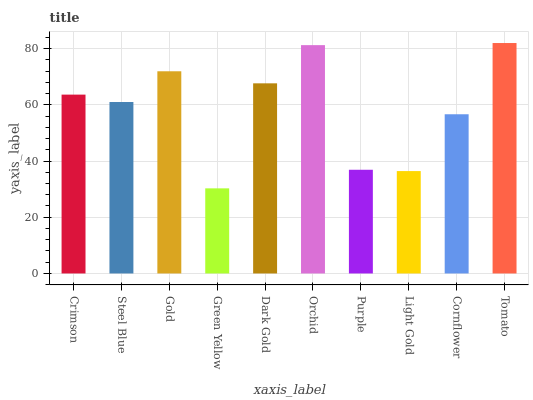Is Green Yellow the minimum?
Answer yes or no. Yes. Is Tomato the maximum?
Answer yes or no. Yes. Is Steel Blue the minimum?
Answer yes or no. No. Is Steel Blue the maximum?
Answer yes or no. No. Is Crimson greater than Steel Blue?
Answer yes or no. Yes. Is Steel Blue less than Crimson?
Answer yes or no. Yes. Is Steel Blue greater than Crimson?
Answer yes or no. No. Is Crimson less than Steel Blue?
Answer yes or no. No. Is Crimson the high median?
Answer yes or no. Yes. Is Steel Blue the low median?
Answer yes or no. Yes. Is Purple the high median?
Answer yes or no. No. Is Gold the low median?
Answer yes or no. No. 